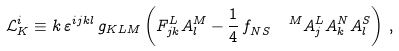<formula> <loc_0><loc_0><loc_500><loc_500>\mathcal { L } _ { K } ^ { i } \equiv k \, \varepsilon ^ { i j k l } \, g _ { K L M } \left ( F _ { j k } ^ { L } A _ { l } ^ { M } - \frac { 1 } { 4 } \, f _ { N S } ^ { \quad \, M } A _ { j } ^ { L } A _ { k } ^ { N } A _ { l } ^ { S } \right ) \, ,</formula> 